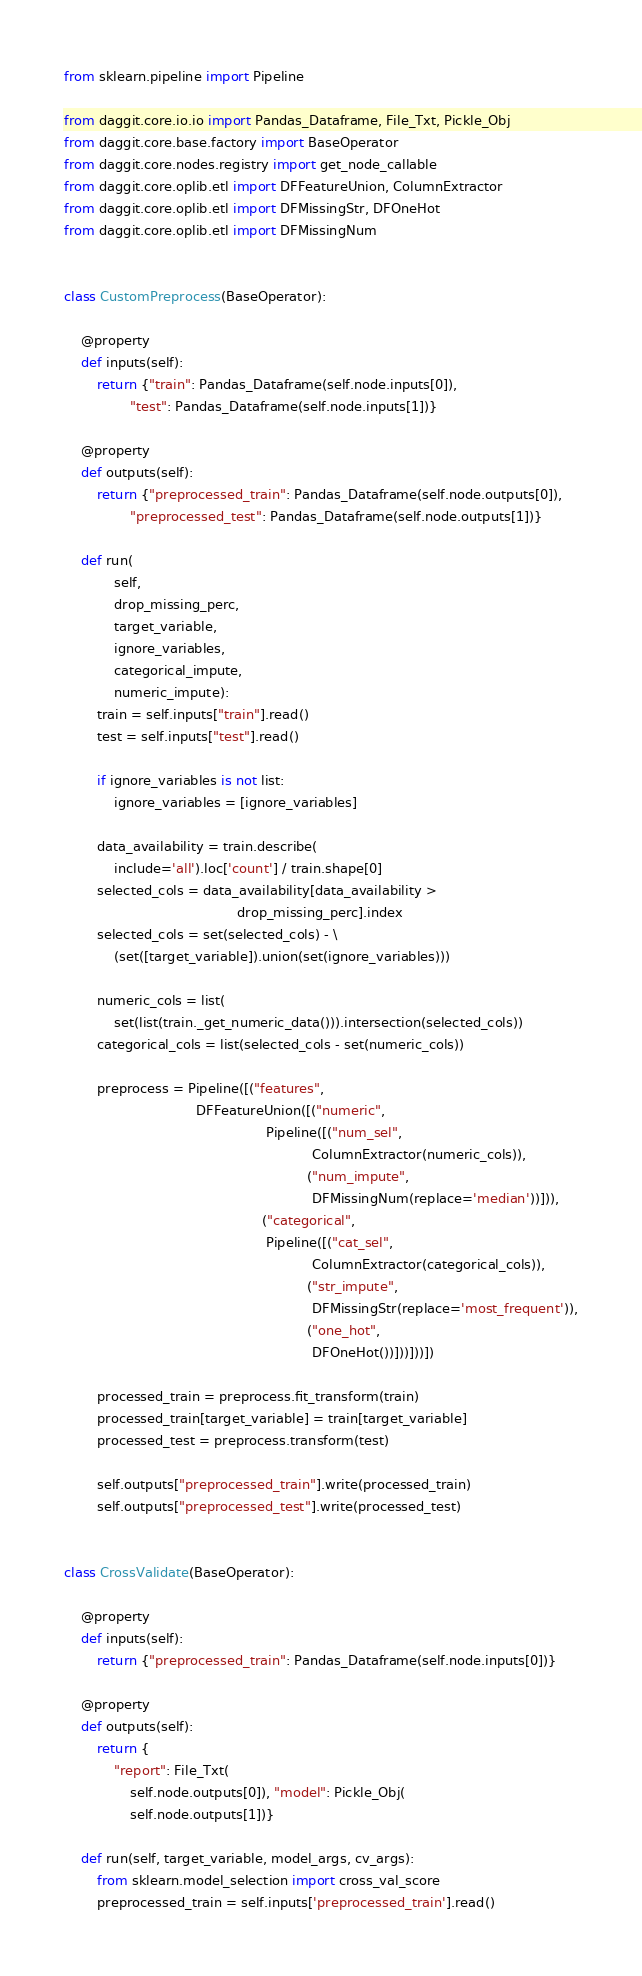<code> <loc_0><loc_0><loc_500><loc_500><_Python_>from sklearn.pipeline import Pipeline

from daggit.core.io.io import Pandas_Dataframe, File_Txt, Pickle_Obj
from daggit.core.base.factory import BaseOperator
from daggit.core.nodes.registry import get_node_callable
from daggit.core.oplib.etl import DFFeatureUnion, ColumnExtractor
from daggit.core.oplib.etl import DFMissingStr, DFOneHot
from daggit.core.oplib.etl import DFMissingNum


class CustomPreprocess(BaseOperator):

    @property
    def inputs(self):
        return {"train": Pandas_Dataframe(self.node.inputs[0]),
                "test": Pandas_Dataframe(self.node.inputs[1])}

    @property
    def outputs(self):
        return {"preprocessed_train": Pandas_Dataframe(self.node.outputs[0]),
                "preprocessed_test": Pandas_Dataframe(self.node.outputs[1])}

    def run(
            self,
            drop_missing_perc,
            target_variable,
            ignore_variables,
            categorical_impute,
            numeric_impute):
        train = self.inputs["train"].read()
        test = self.inputs["test"].read()

        if ignore_variables is not list:
            ignore_variables = [ignore_variables]

        data_availability = train.describe(
            include='all').loc['count'] / train.shape[0]
        selected_cols = data_availability[data_availability >
                                          drop_missing_perc].index
        selected_cols = set(selected_cols) - \
            (set([target_variable]).union(set(ignore_variables)))

        numeric_cols = list(
            set(list(train._get_numeric_data())).intersection(selected_cols))
        categorical_cols = list(selected_cols - set(numeric_cols))

        preprocess = Pipeline([("features",
                                DFFeatureUnion([("numeric",
                                                 Pipeline([("num_sel",
                                                            ColumnExtractor(numeric_cols)),
                                                           ("num_impute",
                                                            DFMissingNum(replace='median'))])),
                                                ("categorical",
                                                 Pipeline([("cat_sel",
                                                            ColumnExtractor(categorical_cols)),
                                                           ("str_impute",
                                                            DFMissingStr(replace='most_frequent')),
                                                           ("one_hot",
                                                            DFOneHot())]))]))])

        processed_train = preprocess.fit_transform(train)
        processed_train[target_variable] = train[target_variable]
        processed_test = preprocess.transform(test)

        self.outputs["preprocessed_train"].write(processed_train)
        self.outputs["preprocessed_test"].write(processed_test)


class CrossValidate(BaseOperator):

    @property
    def inputs(self):
        return {"preprocessed_train": Pandas_Dataframe(self.node.inputs[0])}

    @property
    def outputs(self):
        return {
            "report": File_Txt(
                self.node.outputs[0]), "model": Pickle_Obj(
                self.node.outputs[1])}

    def run(self, target_variable, model_args, cv_args):
        from sklearn.model_selection import cross_val_score
        preprocessed_train = self.inputs['preprocessed_train'].read()
</code> 